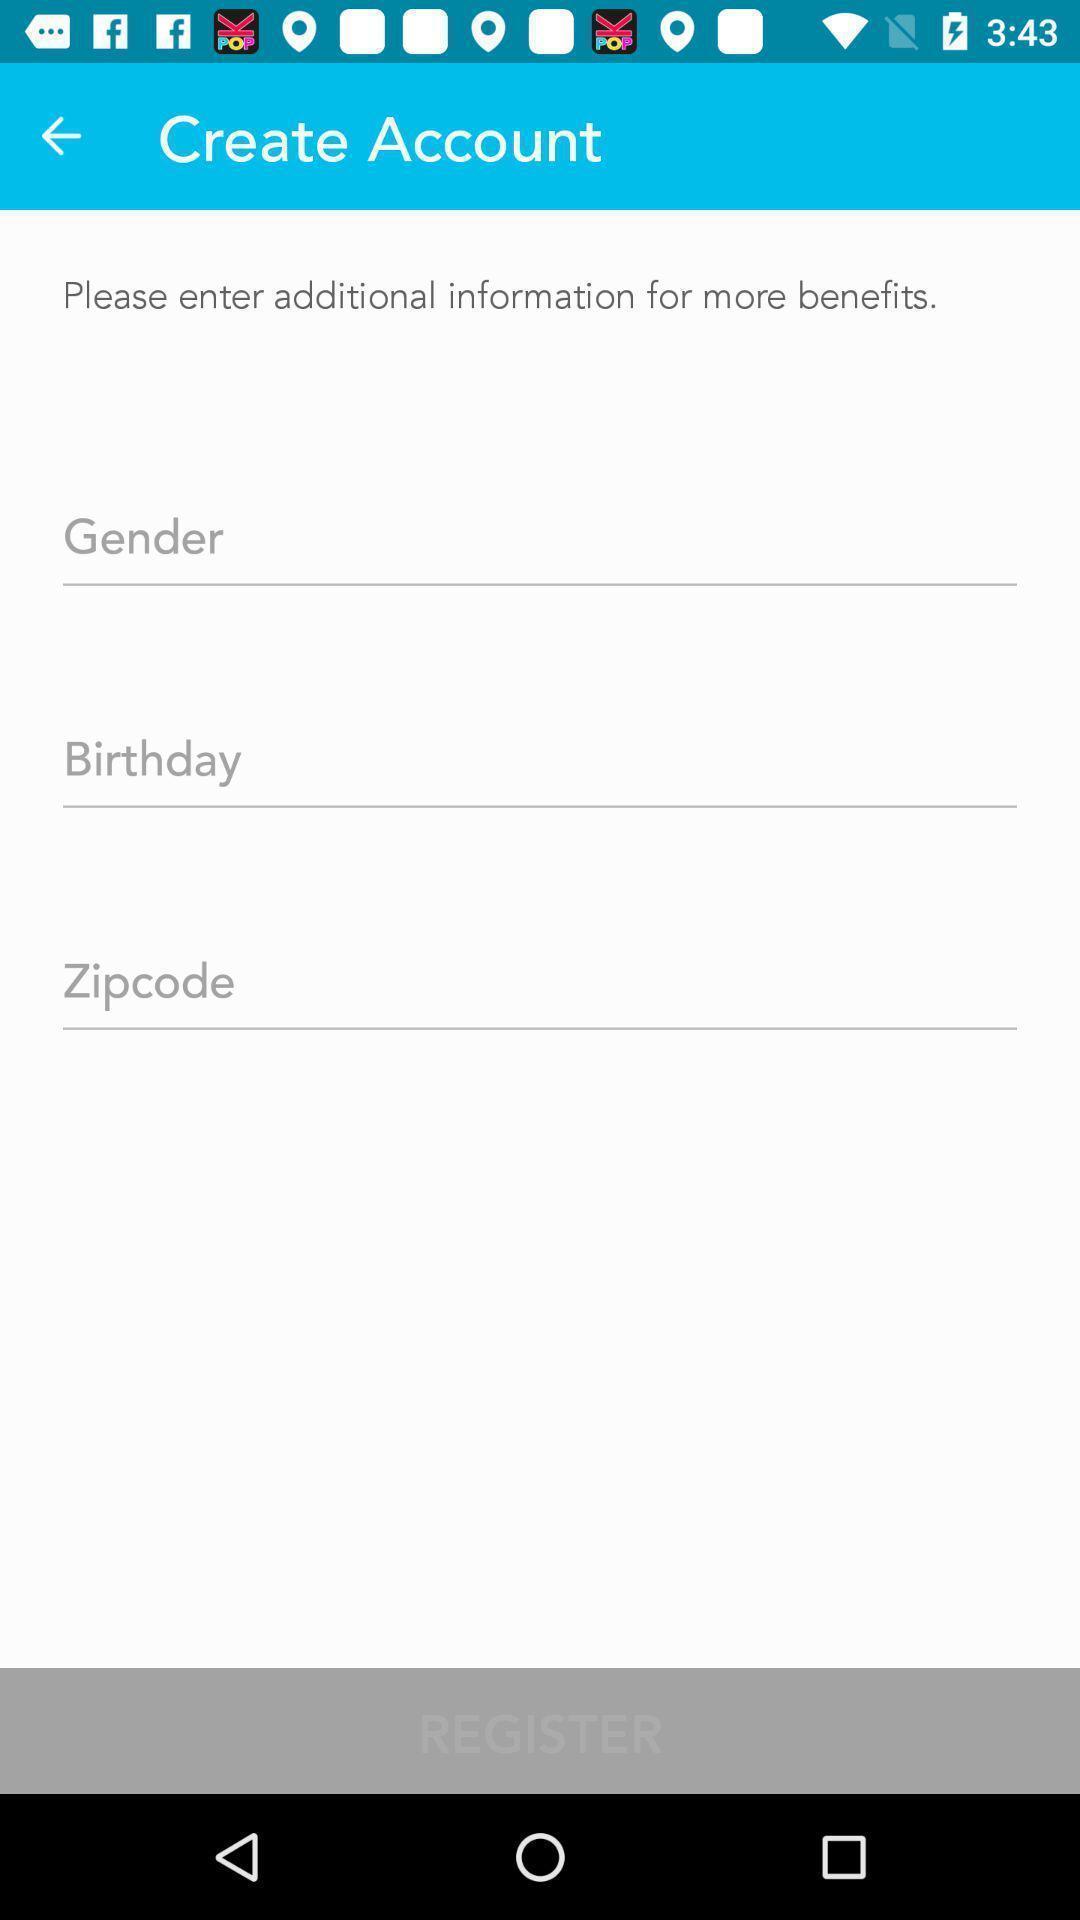What is the overall content of this screenshot? Screen showing create account. 